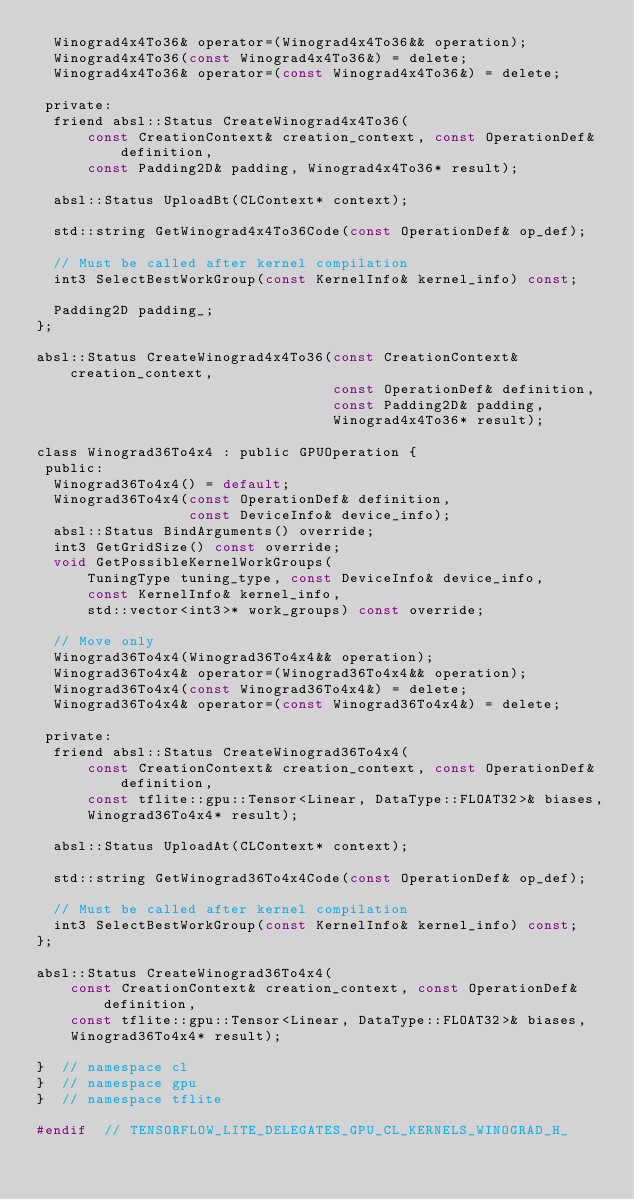Convert code to text. <code><loc_0><loc_0><loc_500><loc_500><_C_>  Winograd4x4To36& operator=(Winograd4x4To36&& operation);
  Winograd4x4To36(const Winograd4x4To36&) = delete;
  Winograd4x4To36& operator=(const Winograd4x4To36&) = delete;

 private:
  friend absl::Status CreateWinograd4x4To36(
      const CreationContext& creation_context, const OperationDef& definition,
      const Padding2D& padding, Winograd4x4To36* result);

  absl::Status UploadBt(CLContext* context);

  std::string GetWinograd4x4To36Code(const OperationDef& op_def);

  // Must be called after kernel compilation
  int3 SelectBestWorkGroup(const KernelInfo& kernel_info) const;

  Padding2D padding_;
};

absl::Status CreateWinograd4x4To36(const CreationContext& creation_context,
                                   const OperationDef& definition,
                                   const Padding2D& padding,
                                   Winograd4x4To36* result);

class Winograd36To4x4 : public GPUOperation {
 public:
  Winograd36To4x4() = default;
  Winograd36To4x4(const OperationDef& definition,
                  const DeviceInfo& device_info);
  absl::Status BindArguments() override;
  int3 GetGridSize() const override;
  void GetPossibleKernelWorkGroups(
      TuningType tuning_type, const DeviceInfo& device_info,
      const KernelInfo& kernel_info,
      std::vector<int3>* work_groups) const override;

  // Move only
  Winograd36To4x4(Winograd36To4x4&& operation);
  Winograd36To4x4& operator=(Winograd36To4x4&& operation);
  Winograd36To4x4(const Winograd36To4x4&) = delete;
  Winograd36To4x4& operator=(const Winograd36To4x4&) = delete;

 private:
  friend absl::Status CreateWinograd36To4x4(
      const CreationContext& creation_context, const OperationDef& definition,
      const tflite::gpu::Tensor<Linear, DataType::FLOAT32>& biases,
      Winograd36To4x4* result);

  absl::Status UploadAt(CLContext* context);

  std::string GetWinograd36To4x4Code(const OperationDef& op_def);

  // Must be called after kernel compilation
  int3 SelectBestWorkGroup(const KernelInfo& kernel_info) const;
};

absl::Status CreateWinograd36To4x4(
    const CreationContext& creation_context, const OperationDef& definition,
    const tflite::gpu::Tensor<Linear, DataType::FLOAT32>& biases,
    Winograd36To4x4* result);

}  // namespace cl
}  // namespace gpu
}  // namespace tflite

#endif  // TENSORFLOW_LITE_DELEGATES_GPU_CL_KERNELS_WINOGRAD_H_
</code> 